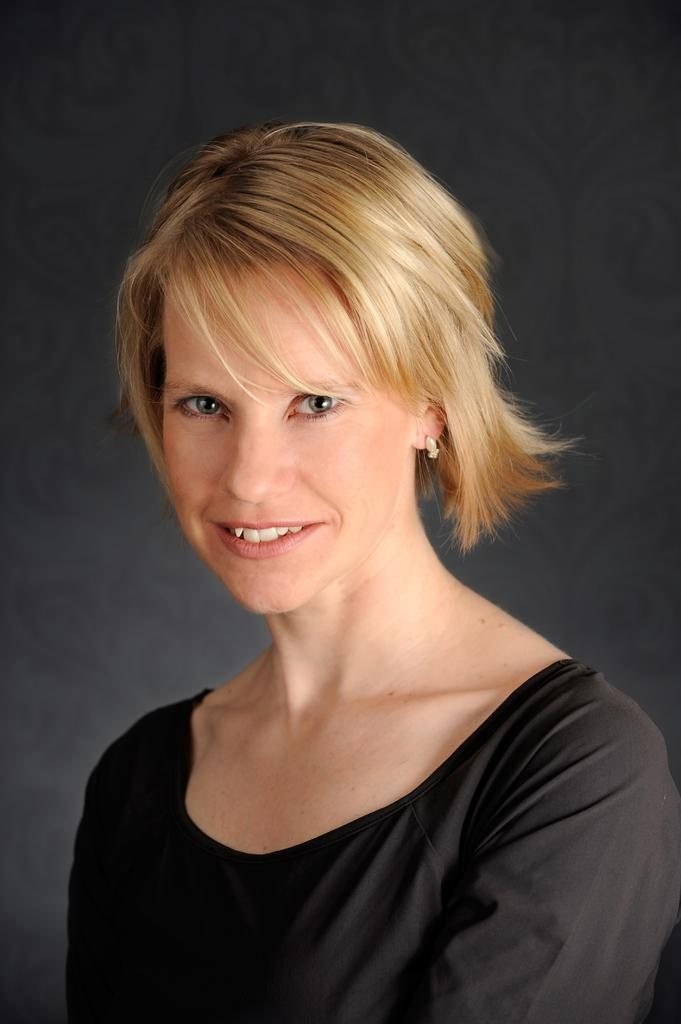Who is the main subject in the image? There is a woman in the image. What is the woman wearing in the image? The woman is wearing a black t-shirt in the image. What can be said about the woman's hair color? The woman's hair is brown in color. What type of bean is being used to support the woman's hair in the image? There is no bean present in the image, and the woman's hair is not being supported by any object. 